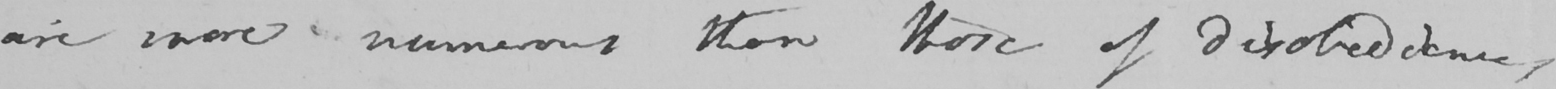What text is written in this handwritten line? are more numerous than those of disobedience , 